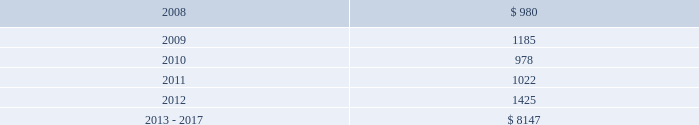Projected payments relating to these liabilities for the next five years ending december 31 , 2012 and the period from 2013 to 2017 are as follows ( in thousands ) : .
( 18 ) concentration of risk the company generates a significant amount of revenue from large customers , however , no customers accounted for more than 10% ( 10 % ) of total revenue or total segment revenue in the years ended december 31 , 2007 , 2006 and 2005 .
Financial instruments that potentially subject the company to concentrations of credit risk consist primarily of cash equivalents and trade receivables .
The company places its cash equivalents with high credit quality financial institutions and , by policy , limits the amount of credit exposure with any one financial institution .
Concentrations of credit risk with respect to trade receivables are limited because a large number of geographically diverse customers make up the company 2019s customer base , thus spreading the trade receivables credit risk .
The company controls credit risk through monitoring procedures .
( 19 ) segment information upon completion of the certegy merger , the company implemented a new organizational structure , which resulted in a new operating segment structure beginning with the reporting of first quarter 2006 results .
Effective as of february 1 , 2006 , the company 2019s operating segments are tps and lps .
This structure reflects how the businesses are operated and managed .
The primary components of the tps segment , which includes certegy 2019s card and check services , the financial institution processing component of the former financial institution software and services segment of fis and the operations acquired from efunds , are enterprise solutions , integrated financial solutions and international businesses .
The primary components of the lps segment are mortgage information services businesses , which includes the mortgage lender processing component of the former financial institution software and services segment of fis , and the former lender services , default management , and information services segments of fis .
Fidelity national information services , inc .
And subsidiaries and affiliates notes to consolidated and combined financial statements 2014 ( continued ) .
What is the growth rate in projected payments from 2009 to 2010? 
Computations: ((978 - 1185) / 1185)
Answer: -0.17468. 